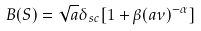Convert formula to latex. <formula><loc_0><loc_0><loc_500><loc_500>B ( S ) = \sqrt { a } \delta _ { s c } [ 1 + \beta ( a \nu ) ^ { - \alpha } ]</formula> 